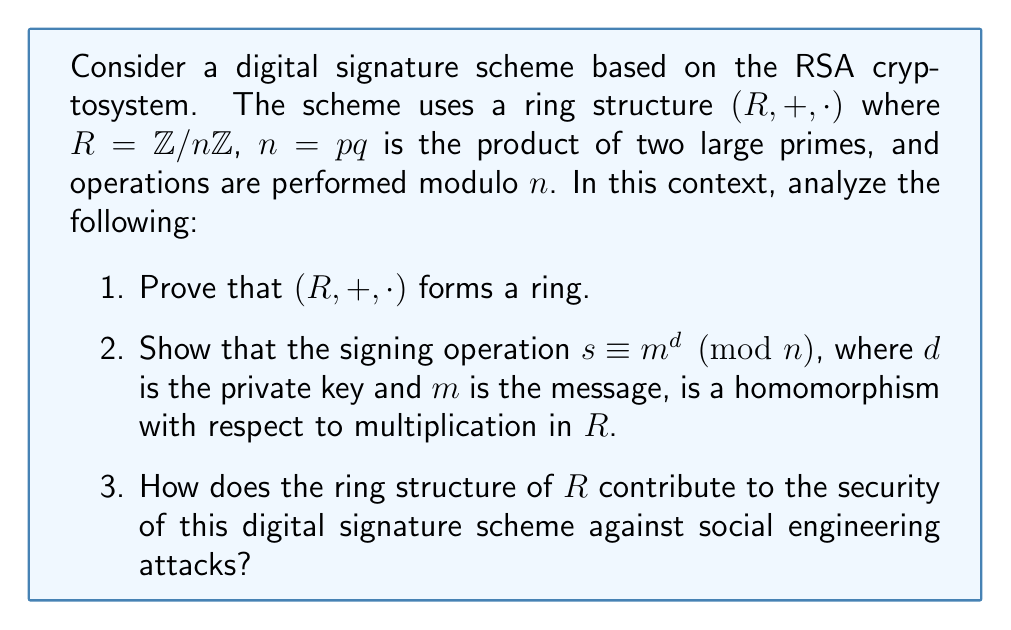What is the answer to this math problem? Let's approach this step-by-step:

1. To prove that $(R, +, \cdot)$ forms a ring, we need to verify the ring axioms:

   a) $(R, +)$ is an abelian group:
      - Closure: For any $a, b \in R$, $a + b \pmod{n} \in R$
      - Associativity: $(a + b) + c \equiv a + (b + c) \pmod{n}$
      - Commutativity: $a + b \equiv b + a \pmod{n}$
      - Identity: $0 + a \equiv a + 0 \equiv a \pmod{n}$
      - Inverse: For any $a \in R$, there exists $-a \in R$ such that $a + (-a) \equiv 0 \pmod{n}$

   b) $(R, \cdot)$ is a monoid:
      - Closure: For any $a, b \in R$, $a \cdot b \pmod{n} \in R$
      - Associativity: $(a \cdot b) \cdot c \equiv a \cdot (b \cdot c) \pmod{n}$
      - Identity: $1 \cdot a \equiv a \cdot 1 \equiv a \pmod{n}$

   c) Distributivity:
      - $a \cdot (b + c) \equiv (a \cdot b) + (a \cdot c) \pmod{n}$
      - $(b + c) \cdot a \equiv (b \cdot a) + (c \cdot a) \pmod{n}$

   All these properties hold in $\mathbb{Z}/n\mathbb{Z}$, thus $(R, +, \cdot)$ forms a ring.

2. To show that the signing operation is a homomorphism with respect to multiplication:

   Let $m_1, m_2 \in R$ be two messages. We need to prove:
   $$(m_1 \cdot m_2)^d \equiv m_1^d \cdot m_2^d \pmod{n}$$

   This holds due to the properties of modular exponentiation:
   $$(m_1 \cdot m_2)^d \equiv m_1^d \cdot m_2^d \pmod{n}$$

   Thus, the signing operation preserves the multiplicative structure of $R$.

3. The ring structure contributes to the security against social engineering attacks in several ways:

   a) Complexity: The ring structure adds mathematical complexity, making it harder for an attacker to exploit human behavior to gain information about the system.

   b) Homomorphic property: The multiplicative homomorphism allows for partial computations on signed data, which can be used to design protocols that reveal minimal information, reducing the attack surface for social engineering.

   c) Algebraic properties: The ring structure enables various algebraic manipulations that can be used to design more sophisticated protocols, making it harder for an attacker to guess or socially engineer critical information.

   d) Abstraction: The abstract nature of ring structures makes it more difficult for non-experts to understand, reducing the risk of inadvertent information leakage through social interactions.
Answer: $(R, +, \cdot)$ forms a ring; signing is multiplicatively homomorphic; ring structure enhances security through complexity, homomorphic properties, algebraic manipulations, and abstraction. 